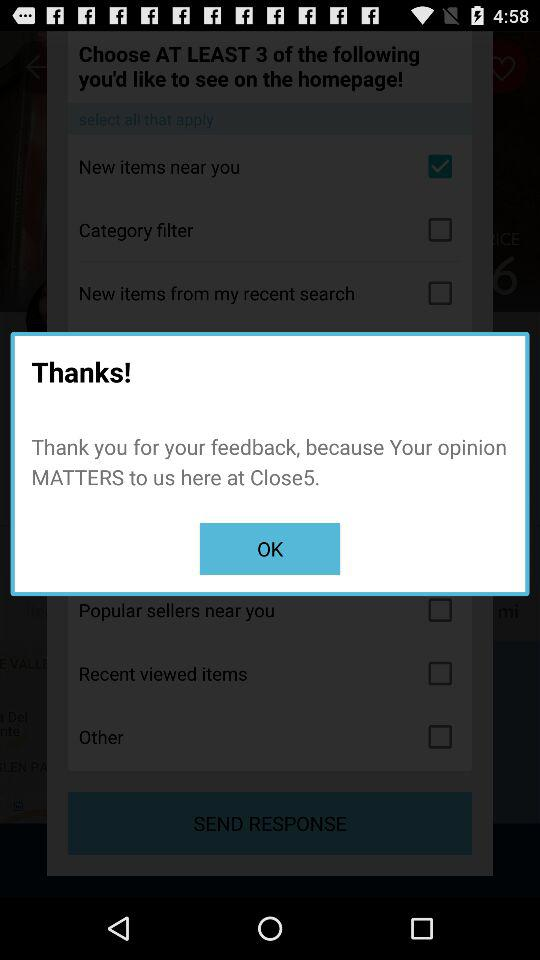Which option is checked? The checked option is "New items near you". 